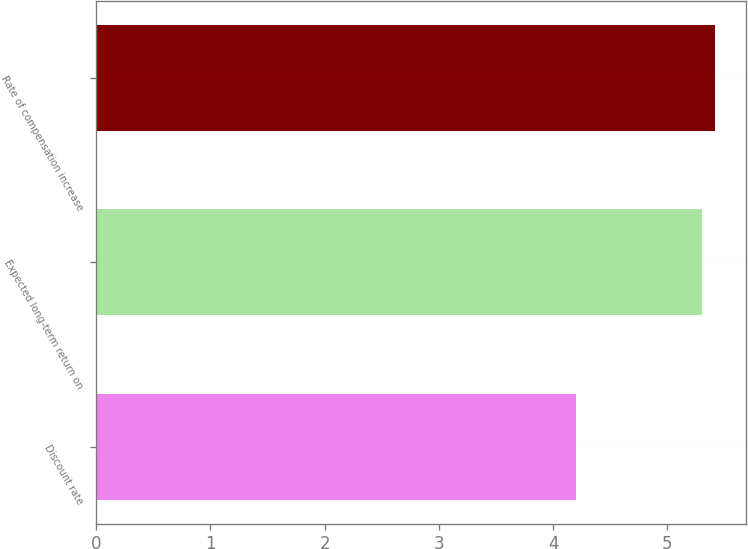<chart> <loc_0><loc_0><loc_500><loc_500><bar_chart><fcel>Discount rate<fcel>Expected long-term return on<fcel>Rate of compensation increase<nl><fcel>4.2<fcel>5.3<fcel>5.42<nl></chart> 